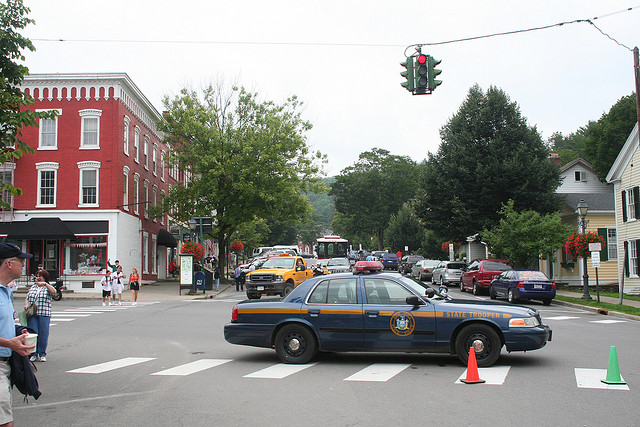<image>What might happen if the blue truck turns left too fast? I don't know what might happen if the blue truck turns left too fast. It could hit another car and cause accident. What might happen if the blue truck turns left too fast? I don't know what might happen if the blue truck turns left too fast. It can potentially hit a police car, another car, or cause an accident. 